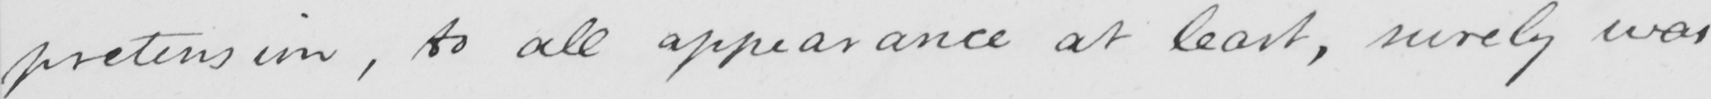Can you read and transcribe this handwriting? pretension , to all appearance at least , surely was 